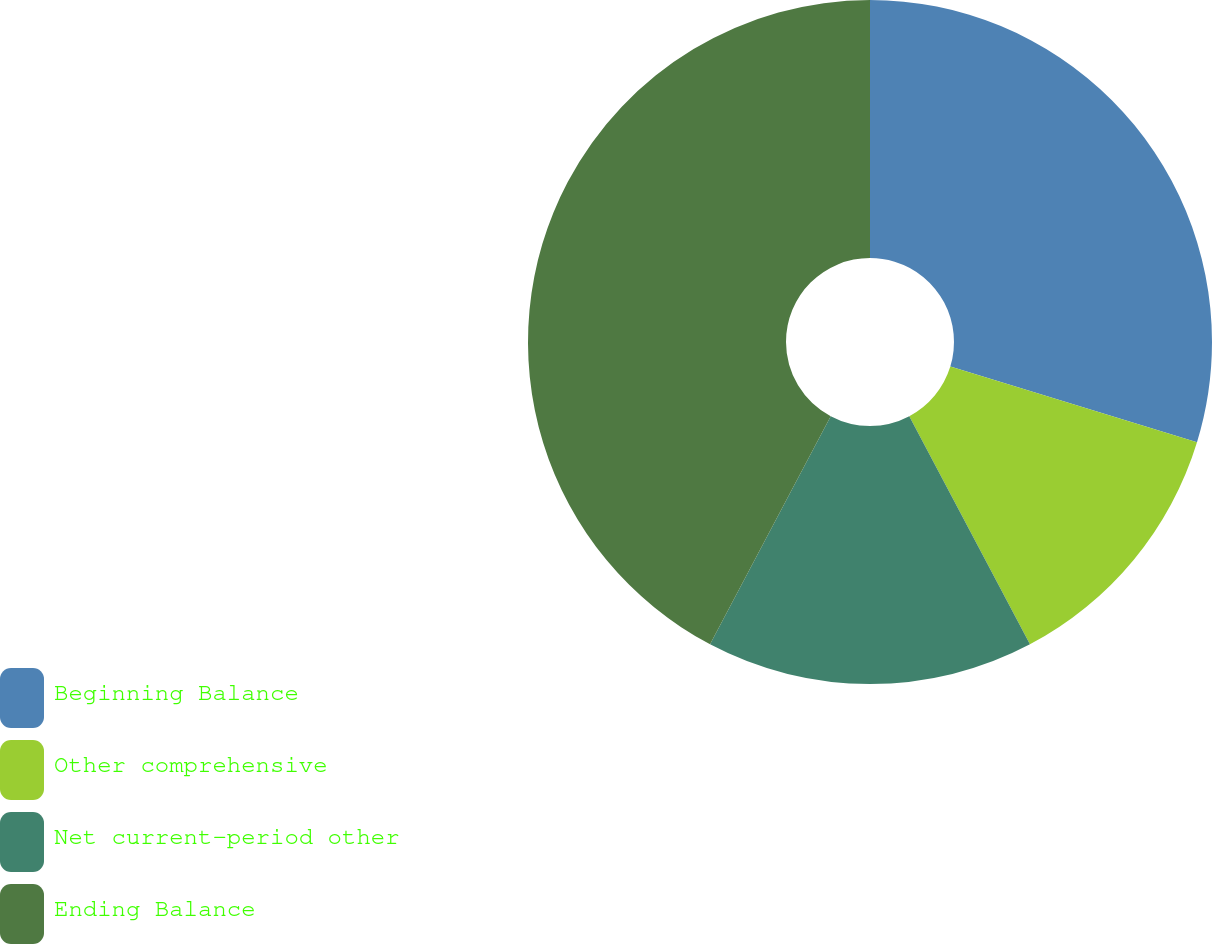<chart> <loc_0><loc_0><loc_500><loc_500><pie_chart><fcel>Beginning Balance<fcel>Other comprehensive<fcel>Net current-period other<fcel>Ending Balance<nl><fcel>29.73%<fcel>12.52%<fcel>15.49%<fcel>42.25%<nl></chart> 